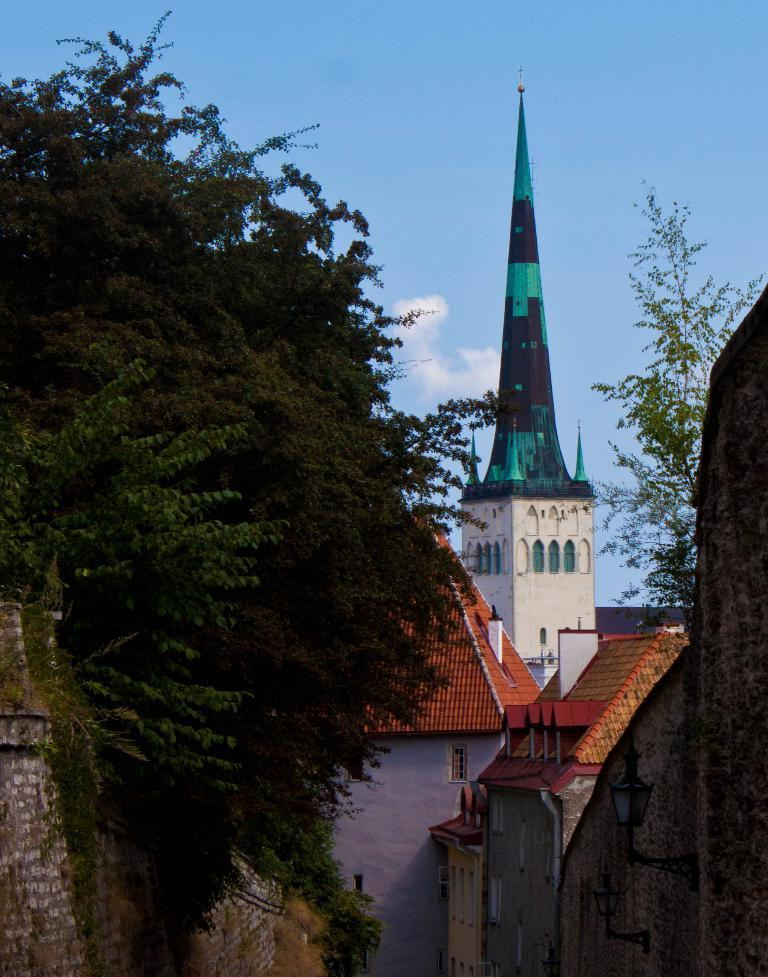Where was the picture taken? The picture was clicked outside. What can be seen on the left side of the image? There are trees on the left side of the image. What type of structures are visible in the image? There are houses in the image. What is the main architectural feature in the center of the image? There is a spire in the center of the image. What is visible in the background of the image? The sky is visible in the background of the image. What type of plant is being discussed by the committee in the image? There is no committee or plant present in the image. How many legs can be seen on the spire in the image? The spire in the image is an architectural feature and does not have legs. 